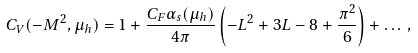<formula> <loc_0><loc_0><loc_500><loc_500>C _ { V } ( - M ^ { 2 } , \mu _ { h } ) = 1 + \frac { C _ { F } \alpha _ { s } ( \mu _ { h } ) } { 4 \pi } \left ( - L ^ { 2 } + 3 L - 8 + \frac { \pi ^ { 2 } } { 6 } \right ) + \dots \, ,</formula> 